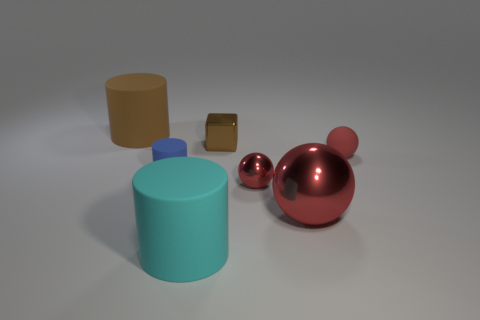Does the image give any hint about the relative sizes of these objects? Yes, the image suggests that the objects have varying sizes. The tall beige cylinder and the large red sphere seem to be the biggest objects in the scene. The small blue sphere is the smallest, and the gold or bronze cube is slightly larger than that small sphere but significantly smaller than the cylinders and large sphere. 